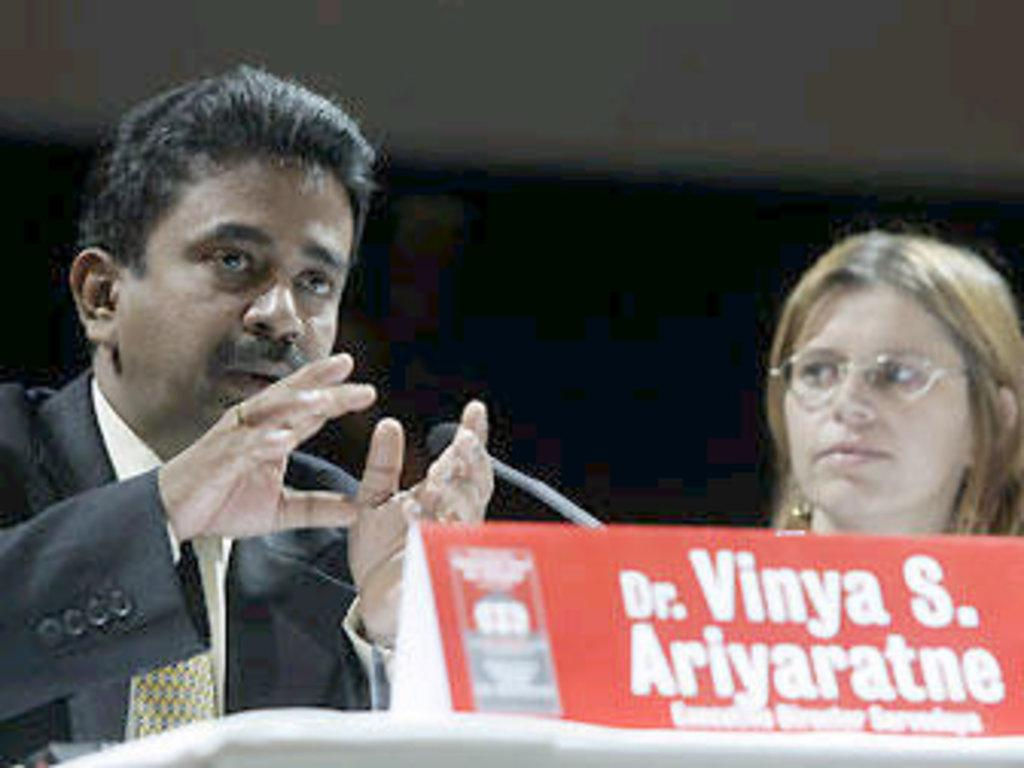What is the main object in the image? There is a name board with text in the image. What can be observed about the text on the name board? The text on the name board is red in color. What else can be seen in the background of the image? There are persons and a mic in the background of the image. Can you tell me how many stalks of celery are being kicked by the person in the image? There is no person kicking celery in the image; it only features a name board with text, persons in the background, and a mic. 